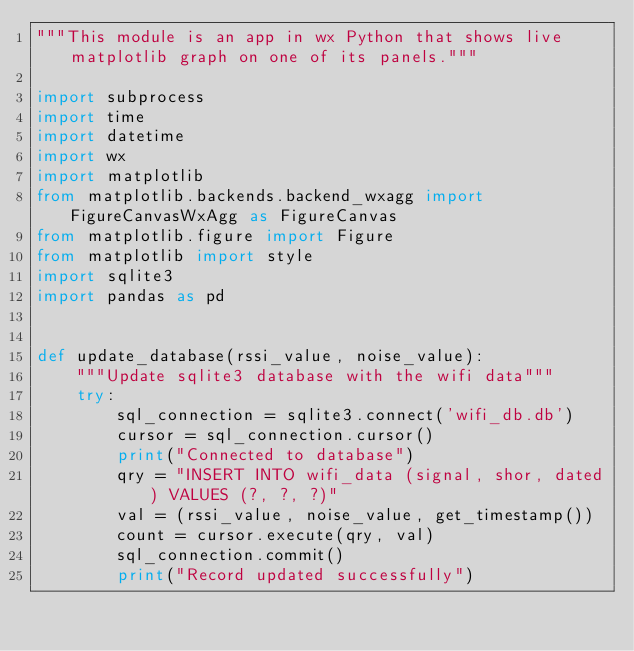<code> <loc_0><loc_0><loc_500><loc_500><_Python_>"""This module is an app in wx Python that shows live matplotlib graph on one of its panels."""

import subprocess
import time
import datetime
import wx
import matplotlib
from matplotlib.backends.backend_wxagg import FigureCanvasWxAgg as FigureCanvas
from matplotlib.figure import Figure
from matplotlib import style
import sqlite3
import pandas as pd


def update_database(rssi_value, noise_value):
    """Update sqlite3 database with the wifi data"""
    try:
        sql_connection = sqlite3.connect('wifi_db.db')
        cursor = sql_connection.cursor()
        print("Connected to database")
        qry = "INSERT INTO wifi_data (signal, shor, dated) VALUES (?, ?, ?)"
        val = (rssi_value, noise_value, get_timestamp())
        count = cursor.execute(qry, val)
        sql_connection.commit()
        print("Record updated successfully")</code> 